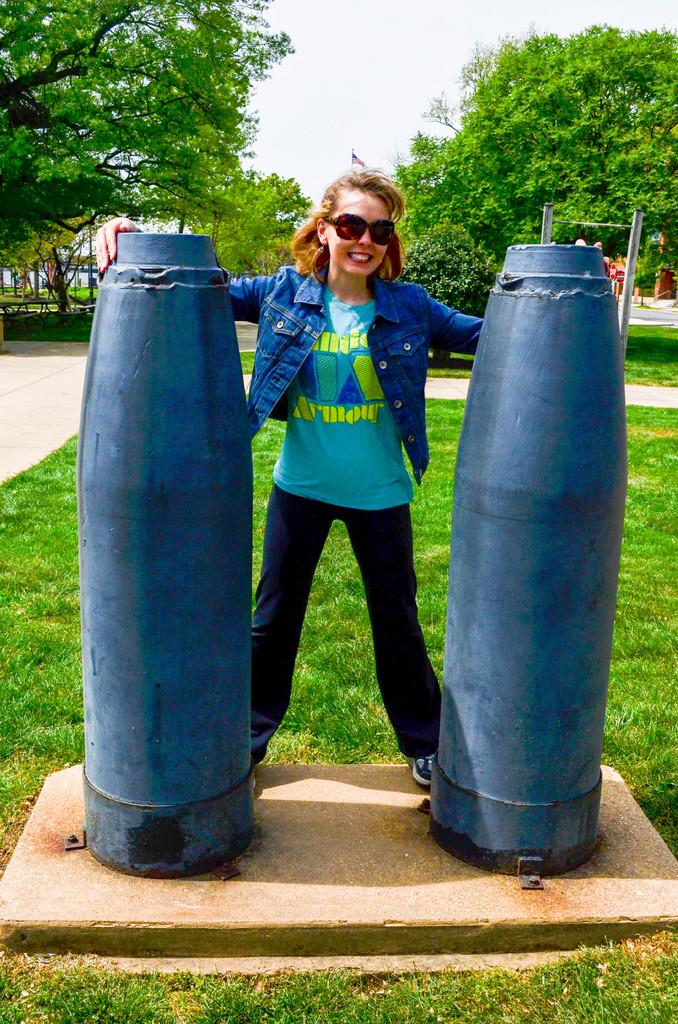Who is present in the image? There is a woman in the image. What is the woman wearing that helps her see better? The woman is wearing spectacles. What is the woman standing between? The woman is standing between metal rods. What type of natural environment is visible in the image? There is grass and trees visible in the image. Can you see a stream flowing in the image? There is no stream visible in the image. What type of pan is the woman using to cook in the image? There is no pan or cooking activity present in the image. 